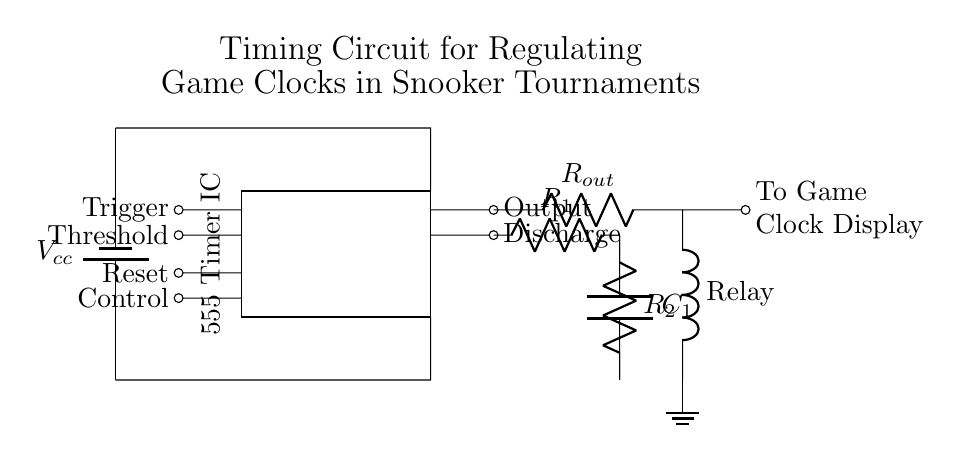What is the main power supply voltage? The main power supply is labeled as Vcc, which typically represents a direct current voltage. It is essential to read the labeling of components to identify the expected voltage.
Answer: Vcc What are the timing components used in this circuit? The timing components consist of two resistors (R1 and R2) and one capacitor (C1). These components work together to set the timing intervals for the clock.
Answer: R1, R2, C1 How many outputs does the 555 Timer IC have? The 555 Timer has two outputs indicated in the circuit as Output and Discharge. To find this, you identify the components connected to the output of the timer on the circuit diagram.
Answer: Two What is the role of the Relay in this circuit? The Relay acts as a control switch which can activate or deactivate the game clock display based on the output from the timer. It is used to separate the timings from the actual game display.
Answer: Control switch Which component resets the timer? The Reset pin, connected to the 555 Timer, is responsible for resetting the timer. Identifying the pins of the 555 Timer helps in understanding its functionality regarding resetting.
Answer: Reset What is connected to the output of the timer? The output of the timer is connected to a resistor labeled as Rout, followed by a relay that leads to the ground. Checking the connections coming off the timer provides this information.
Answer: R_out, Relay How does the game clock display receive its signal? The signal is transmitted from the timer output through the relay to the game clock display. Understanding circuit flow and connections helps clarify how components communicate within the layout.
Answer: To game clock display 